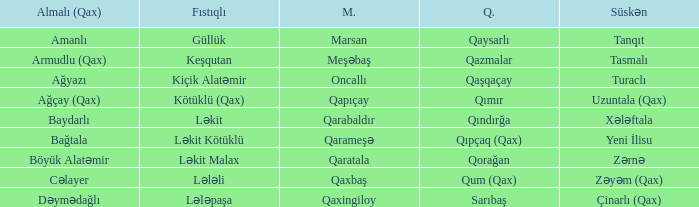What is the Almali village with the Malax village qaxingiloy? Dəymədağlı. 